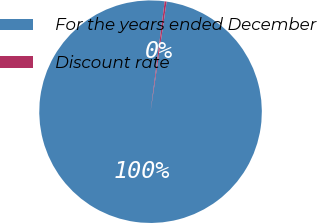<chart> <loc_0><loc_0><loc_500><loc_500><pie_chart><fcel>For the years ended December<fcel>Discount rate<nl><fcel>99.72%<fcel>0.28%<nl></chart> 